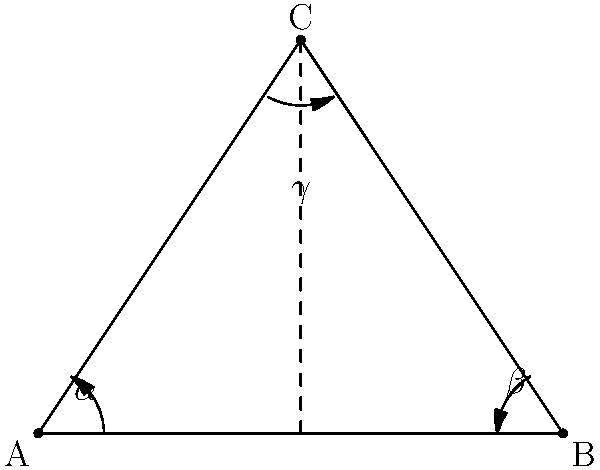In a three-point lighting setup for your latest avant-garde film, the key light, fill light, and back light form a triangle ABC as shown. If $\alpha = 30°$ and $\beta = 50°$, what is the measure of angle $\gamma$ at the apex of the triangle? Let's approach this step-by-step:

1) In any triangle, the sum of all interior angles is always 180°. This is a fundamental property of triangles.

2) We are given two angles of the triangle:
   $\alpha = 30°$
   $\beta = 50°$

3) Let's call the unknown angle $\gamma$. We can set up an equation:

   $\alpha + \beta + \gamma = 180°$

4) Substituting the known values:

   $30° + 50° + \gamma = 180°$

5) Simplifying:

   $80° + \gamma = 180°$

6) Subtracting 80° from both sides:

   $\gamma = 180° - 80° = 100°$

Therefore, the measure of angle $\gamma$ at the apex of the triangle is 100°.
Answer: $100°$ 